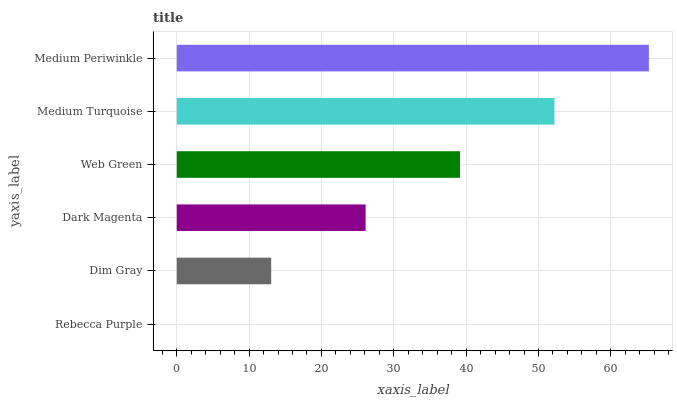Is Rebecca Purple the minimum?
Answer yes or no. Yes. Is Medium Periwinkle the maximum?
Answer yes or no. Yes. Is Dim Gray the minimum?
Answer yes or no. No. Is Dim Gray the maximum?
Answer yes or no. No. Is Dim Gray greater than Rebecca Purple?
Answer yes or no. Yes. Is Rebecca Purple less than Dim Gray?
Answer yes or no. Yes. Is Rebecca Purple greater than Dim Gray?
Answer yes or no. No. Is Dim Gray less than Rebecca Purple?
Answer yes or no. No. Is Web Green the high median?
Answer yes or no. Yes. Is Dark Magenta the low median?
Answer yes or no. Yes. Is Medium Periwinkle the high median?
Answer yes or no. No. Is Dim Gray the low median?
Answer yes or no. No. 